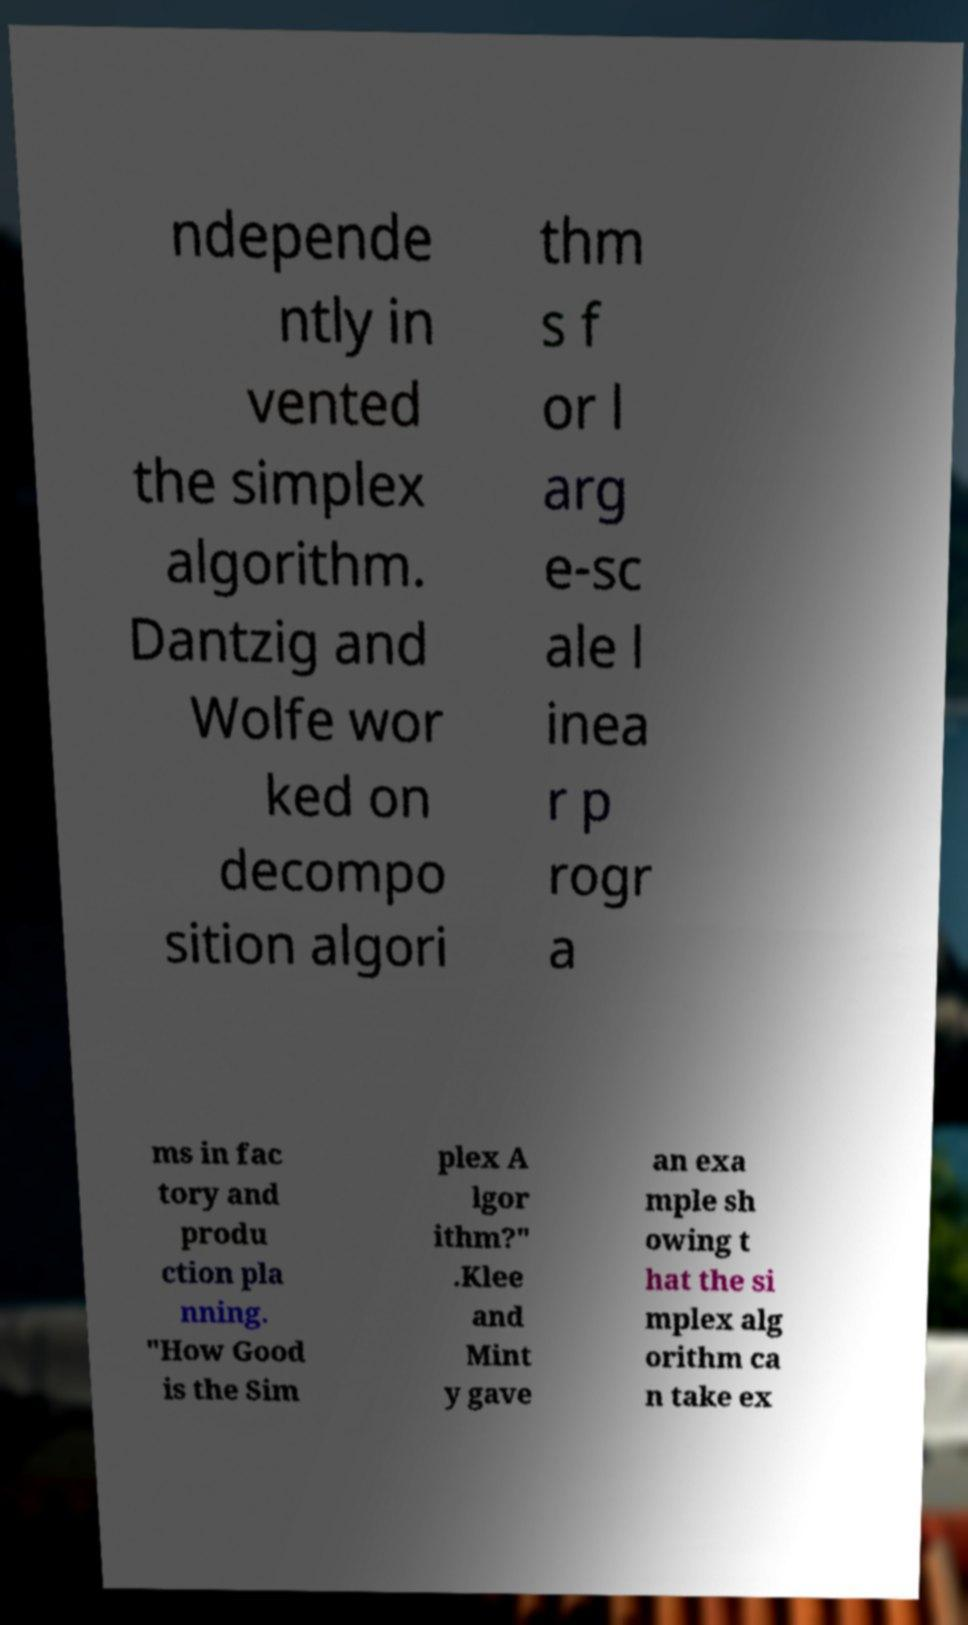Please read and relay the text visible in this image. What does it say? ndepende ntly in vented the simplex algorithm. Dantzig and Wolfe wor ked on decompo sition algori thm s f or l arg e-sc ale l inea r p rogr a ms in fac tory and produ ction pla nning. "How Good is the Sim plex A lgor ithm?" .Klee and Mint y gave an exa mple sh owing t hat the si mplex alg orithm ca n take ex 